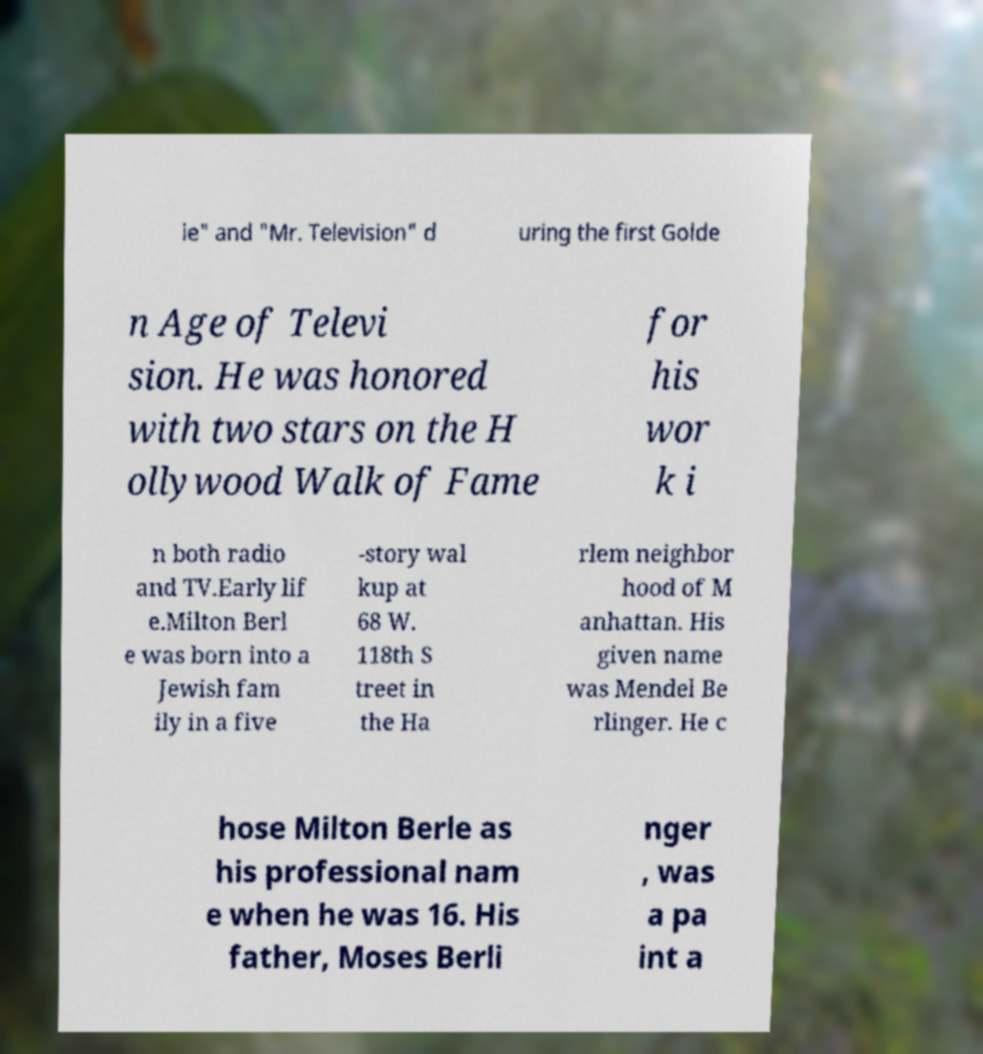Could you assist in decoding the text presented in this image and type it out clearly? ie" and "Mr. Television" d uring the first Golde n Age of Televi sion. He was honored with two stars on the H ollywood Walk of Fame for his wor k i n both radio and TV.Early lif e.Milton Berl e was born into a Jewish fam ily in a five -story wal kup at 68 W. 118th S treet in the Ha rlem neighbor hood of M anhattan. His given name was Mendel Be rlinger. He c hose Milton Berle as his professional nam e when he was 16. His father, Moses Berli nger , was a pa int a 